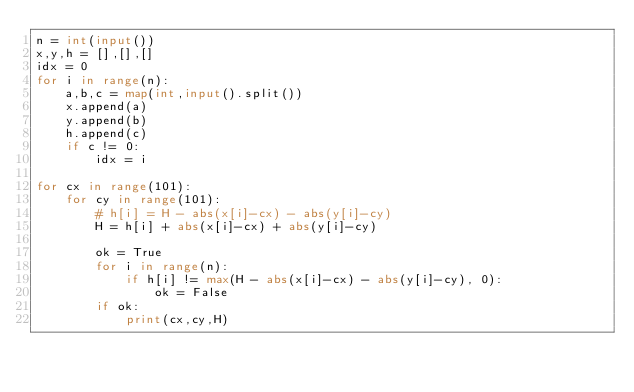<code> <loc_0><loc_0><loc_500><loc_500><_Python_>n = int(input())
x,y,h = [],[],[]
idx = 0
for i in range(n):
    a,b,c = map(int,input().split())
    x.append(a)
    y.append(b)
    h.append(c)
    if c != 0:
        idx = i

for cx in range(101):
    for cy in range(101):
        # h[i] = H - abs(x[i]-cx) - abs(y[i]-cy)
        H = h[i] + abs(x[i]-cx) + abs(y[i]-cy)

        ok = True
        for i in range(n):
            if h[i] != max(H - abs(x[i]-cx) - abs(y[i]-cy), 0):
                ok = False
        if ok:
            print(cx,cy,H)
</code> 